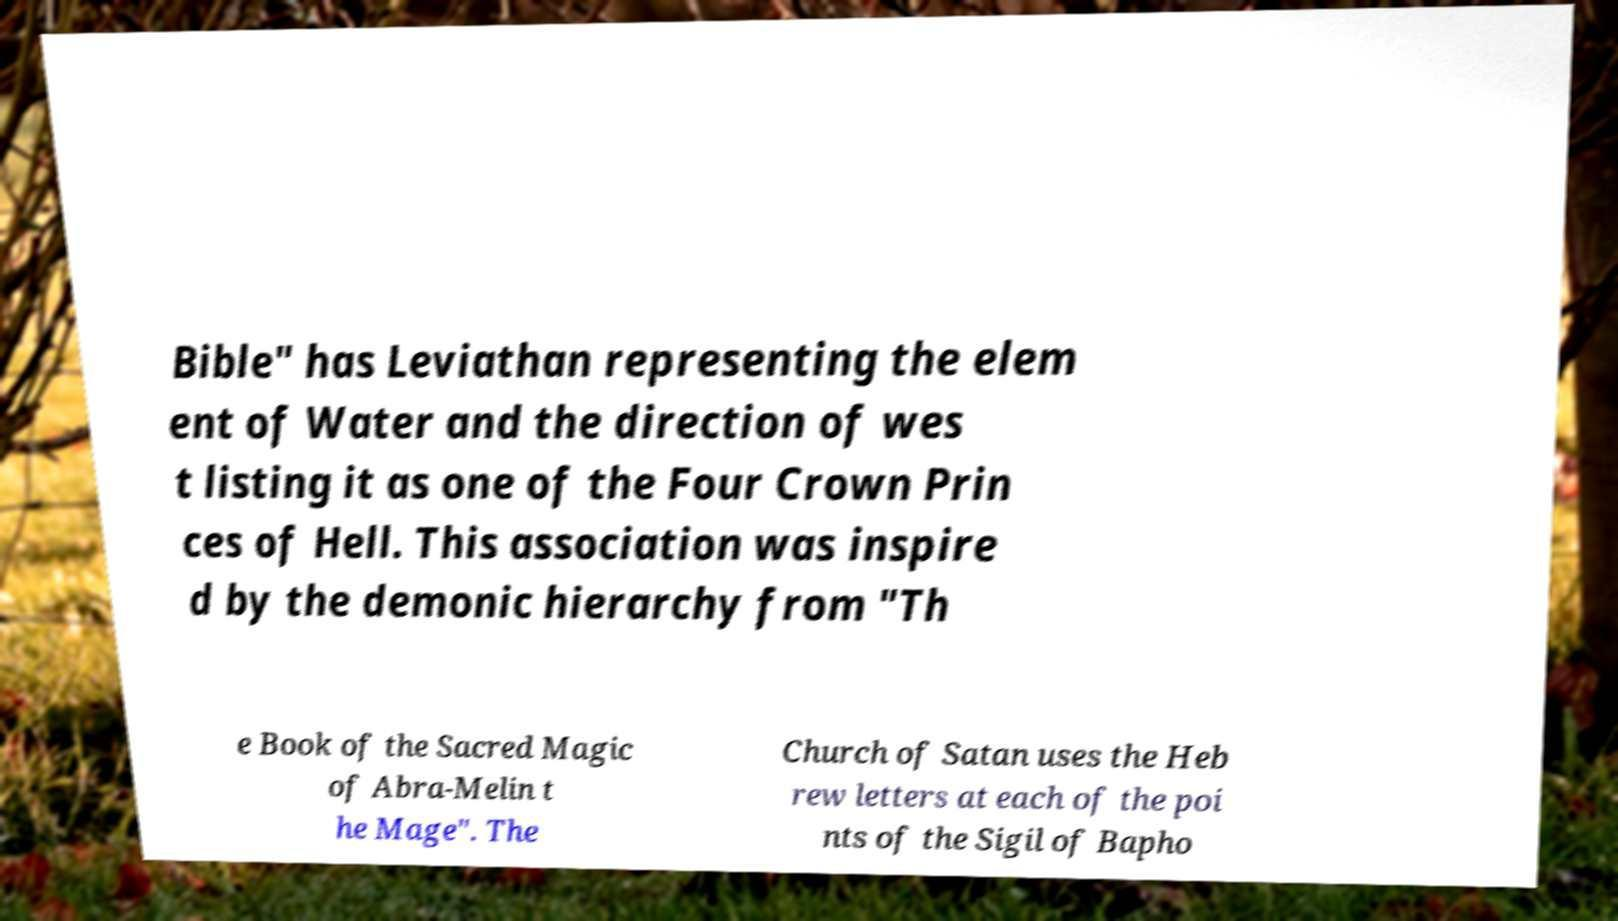Can you accurately transcribe the text from the provided image for me? Bible" has Leviathan representing the elem ent of Water and the direction of wes t listing it as one of the Four Crown Prin ces of Hell. This association was inspire d by the demonic hierarchy from "Th e Book of the Sacred Magic of Abra-Melin t he Mage". The Church of Satan uses the Heb rew letters at each of the poi nts of the Sigil of Bapho 